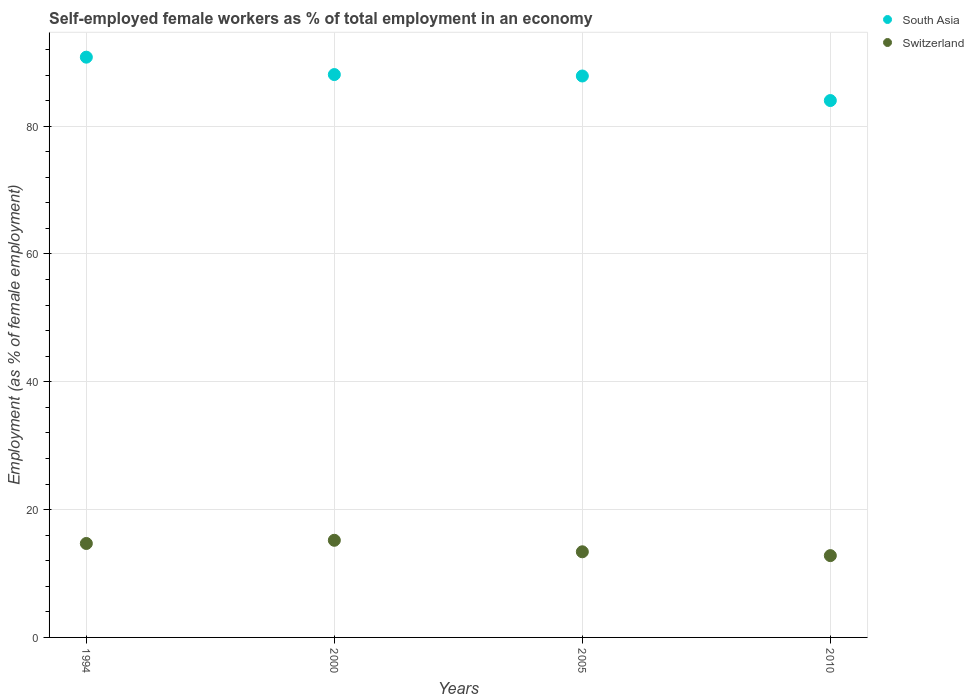What is the percentage of self-employed female workers in South Asia in 2005?
Your answer should be compact. 87.85. Across all years, what is the maximum percentage of self-employed female workers in Switzerland?
Give a very brief answer. 15.2. Across all years, what is the minimum percentage of self-employed female workers in Switzerland?
Your response must be concise. 12.8. In which year was the percentage of self-employed female workers in Switzerland maximum?
Offer a very short reply. 2000. What is the total percentage of self-employed female workers in South Asia in the graph?
Your response must be concise. 350.72. What is the difference between the percentage of self-employed female workers in South Asia in 2000 and that in 2005?
Offer a terse response. 0.22. What is the difference between the percentage of self-employed female workers in Switzerland in 1994 and the percentage of self-employed female workers in South Asia in 2000?
Your response must be concise. -73.37. What is the average percentage of self-employed female workers in Switzerland per year?
Make the answer very short. 14.02. In the year 1994, what is the difference between the percentage of self-employed female workers in South Asia and percentage of self-employed female workers in Switzerland?
Give a very brief answer. 76.09. What is the ratio of the percentage of self-employed female workers in Switzerland in 1994 to that in 2010?
Your response must be concise. 1.15. What is the difference between the highest and the lowest percentage of self-employed female workers in Switzerland?
Make the answer very short. 2.4. In how many years, is the percentage of self-employed female workers in Switzerland greater than the average percentage of self-employed female workers in Switzerland taken over all years?
Offer a very short reply. 2. Does the percentage of self-employed female workers in Switzerland monotonically increase over the years?
Your response must be concise. No. Is the percentage of self-employed female workers in South Asia strictly less than the percentage of self-employed female workers in Switzerland over the years?
Provide a short and direct response. No. How many dotlines are there?
Provide a short and direct response. 2. Are the values on the major ticks of Y-axis written in scientific E-notation?
Keep it short and to the point. No. Does the graph contain any zero values?
Your answer should be compact. No. How are the legend labels stacked?
Offer a very short reply. Vertical. What is the title of the graph?
Your answer should be compact. Self-employed female workers as % of total employment in an economy. Does "Trinidad and Tobago" appear as one of the legend labels in the graph?
Keep it short and to the point. No. What is the label or title of the Y-axis?
Keep it short and to the point. Employment (as % of female employment). What is the Employment (as % of female employment) of South Asia in 1994?
Your answer should be very brief. 90.79. What is the Employment (as % of female employment) of Switzerland in 1994?
Provide a succinct answer. 14.7. What is the Employment (as % of female employment) of South Asia in 2000?
Offer a terse response. 88.07. What is the Employment (as % of female employment) of Switzerland in 2000?
Provide a short and direct response. 15.2. What is the Employment (as % of female employment) in South Asia in 2005?
Offer a terse response. 87.85. What is the Employment (as % of female employment) in Switzerland in 2005?
Provide a short and direct response. 13.4. What is the Employment (as % of female employment) in South Asia in 2010?
Keep it short and to the point. 84.01. What is the Employment (as % of female employment) of Switzerland in 2010?
Make the answer very short. 12.8. Across all years, what is the maximum Employment (as % of female employment) in South Asia?
Offer a terse response. 90.79. Across all years, what is the maximum Employment (as % of female employment) of Switzerland?
Offer a very short reply. 15.2. Across all years, what is the minimum Employment (as % of female employment) of South Asia?
Your answer should be compact. 84.01. Across all years, what is the minimum Employment (as % of female employment) of Switzerland?
Offer a terse response. 12.8. What is the total Employment (as % of female employment) of South Asia in the graph?
Your response must be concise. 350.72. What is the total Employment (as % of female employment) in Switzerland in the graph?
Give a very brief answer. 56.1. What is the difference between the Employment (as % of female employment) in South Asia in 1994 and that in 2000?
Your answer should be very brief. 2.72. What is the difference between the Employment (as % of female employment) of South Asia in 1994 and that in 2005?
Your answer should be very brief. 2.95. What is the difference between the Employment (as % of female employment) in South Asia in 1994 and that in 2010?
Provide a succinct answer. 6.79. What is the difference between the Employment (as % of female employment) in Switzerland in 1994 and that in 2010?
Make the answer very short. 1.9. What is the difference between the Employment (as % of female employment) in South Asia in 2000 and that in 2005?
Your response must be concise. 0.22. What is the difference between the Employment (as % of female employment) in South Asia in 2000 and that in 2010?
Your answer should be compact. 4.07. What is the difference between the Employment (as % of female employment) of South Asia in 2005 and that in 2010?
Offer a terse response. 3.84. What is the difference between the Employment (as % of female employment) in Switzerland in 2005 and that in 2010?
Provide a short and direct response. 0.6. What is the difference between the Employment (as % of female employment) of South Asia in 1994 and the Employment (as % of female employment) of Switzerland in 2000?
Keep it short and to the point. 75.59. What is the difference between the Employment (as % of female employment) of South Asia in 1994 and the Employment (as % of female employment) of Switzerland in 2005?
Offer a very short reply. 77.39. What is the difference between the Employment (as % of female employment) of South Asia in 1994 and the Employment (as % of female employment) of Switzerland in 2010?
Keep it short and to the point. 77.99. What is the difference between the Employment (as % of female employment) in South Asia in 2000 and the Employment (as % of female employment) in Switzerland in 2005?
Give a very brief answer. 74.67. What is the difference between the Employment (as % of female employment) in South Asia in 2000 and the Employment (as % of female employment) in Switzerland in 2010?
Give a very brief answer. 75.27. What is the difference between the Employment (as % of female employment) in South Asia in 2005 and the Employment (as % of female employment) in Switzerland in 2010?
Give a very brief answer. 75.05. What is the average Employment (as % of female employment) in South Asia per year?
Your response must be concise. 87.68. What is the average Employment (as % of female employment) in Switzerland per year?
Make the answer very short. 14.03. In the year 1994, what is the difference between the Employment (as % of female employment) of South Asia and Employment (as % of female employment) of Switzerland?
Your response must be concise. 76.09. In the year 2000, what is the difference between the Employment (as % of female employment) in South Asia and Employment (as % of female employment) in Switzerland?
Provide a short and direct response. 72.87. In the year 2005, what is the difference between the Employment (as % of female employment) of South Asia and Employment (as % of female employment) of Switzerland?
Ensure brevity in your answer.  74.45. In the year 2010, what is the difference between the Employment (as % of female employment) of South Asia and Employment (as % of female employment) of Switzerland?
Keep it short and to the point. 71.21. What is the ratio of the Employment (as % of female employment) in South Asia in 1994 to that in 2000?
Your response must be concise. 1.03. What is the ratio of the Employment (as % of female employment) in Switzerland in 1994 to that in 2000?
Keep it short and to the point. 0.97. What is the ratio of the Employment (as % of female employment) of South Asia in 1994 to that in 2005?
Provide a succinct answer. 1.03. What is the ratio of the Employment (as % of female employment) in Switzerland in 1994 to that in 2005?
Give a very brief answer. 1.1. What is the ratio of the Employment (as % of female employment) in South Asia in 1994 to that in 2010?
Your answer should be very brief. 1.08. What is the ratio of the Employment (as % of female employment) of Switzerland in 1994 to that in 2010?
Make the answer very short. 1.15. What is the ratio of the Employment (as % of female employment) of South Asia in 2000 to that in 2005?
Your response must be concise. 1. What is the ratio of the Employment (as % of female employment) of Switzerland in 2000 to that in 2005?
Ensure brevity in your answer.  1.13. What is the ratio of the Employment (as % of female employment) of South Asia in 2000 to that in 2010?
Your answer should be compact. 1.05. What is the ratio of the Employment (as % of female employment) of Switzerland in 2000 to that in 2010?
Your answer should be compact. 1.19. What is the ratio of the Employment (as % of female employment) of South Asia in 2005 to that in 2010?
Provide a short and direct response. 1.05. What is the ratio of the Employment (as % of female employment) of Switzerland in 2005 to that in 2010?
Keep it short and to the point. 1.05. What is the difference between the highest and the second highest Employment (as % of female employment) in South Asia?
Give a very brief answer. 2.72. What is the difference between the highest and the lowest Employment (as % of female employment) in South Asia?
Ensure brevity in your answer.  6.79. 